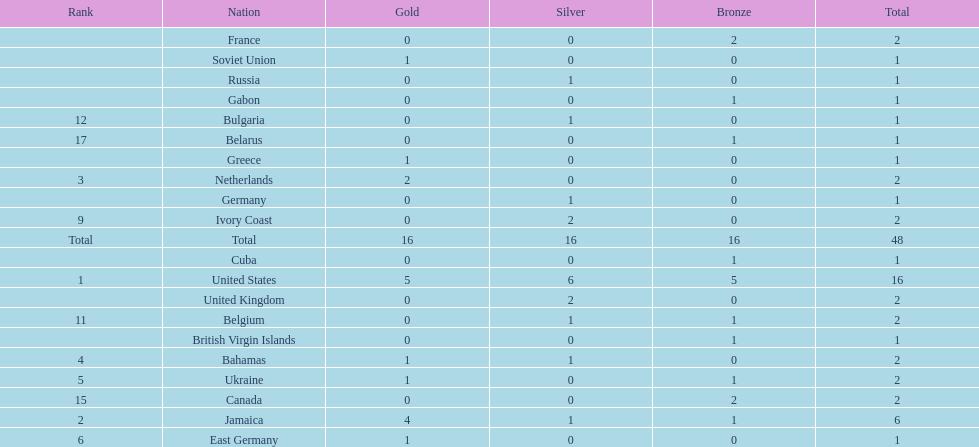After the united states, what country won the most gold medals. Jamaica. 